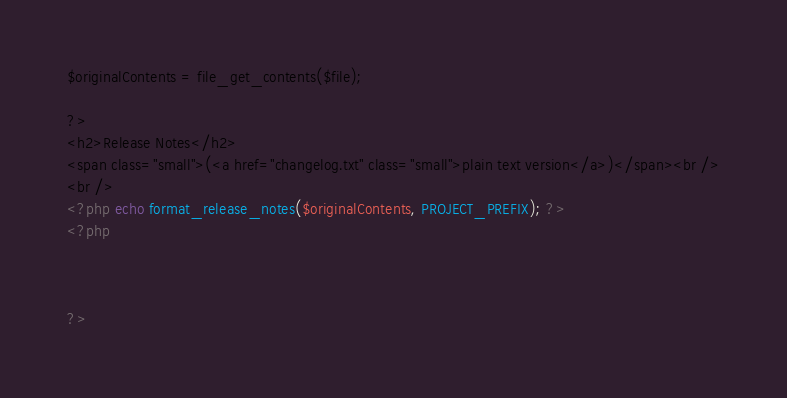Convert code to text. <code><loc_0><loc_0><loc_500><loc_500><_PHP_>
$originalContents = file_get_contents($file);

?>
<h2>Release Notes</h2>
<span class="small">(<a href="changelog.txt" class="small">plain text version</a>)</span><br />
<br />
<?php echo format_release_notes($originalContents, PROJECT_PREFIX); ?>
<?php



?>
</code> 